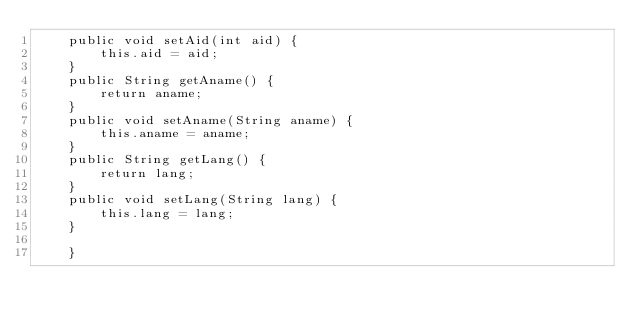Convert code to text. <code><loc_0><loc_0><loc_500><loc_500><_Java_>	public void setAid(int aid) {
		this.aid = aid;
	}
	public String getAname() {
		return aname;
	}
	public void setAname(String aname) {
		this.aname = aname;
	}
	public String getLang() {
		return lang;
	}
	public void setLang(String lang) {
		this.lang = lang;
	}
	
	}
</code> 